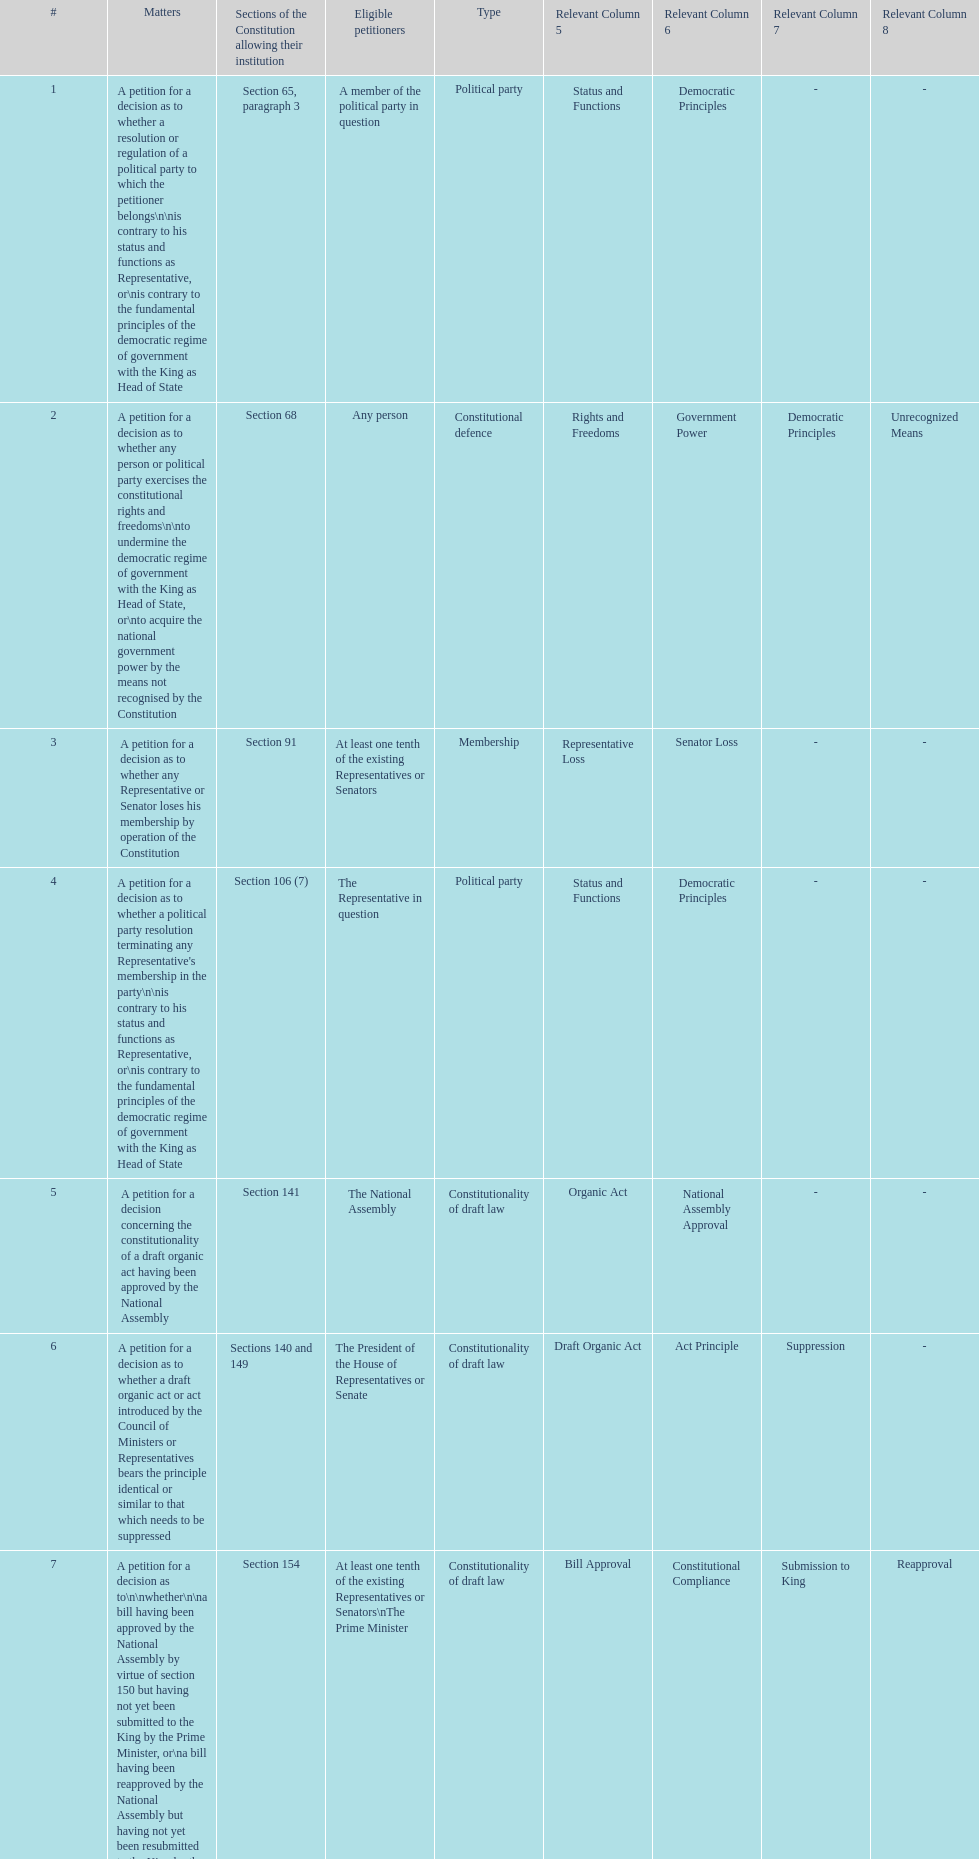How many matters require at least one tenth of the existing representatives or senators? 7. 